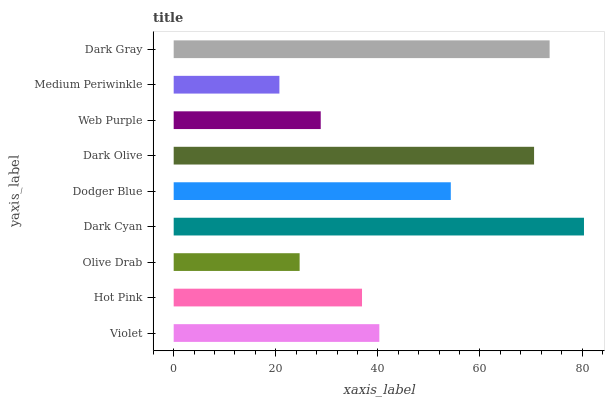Is Medium Periwinkle the minimum?
Answer yes or no. Yes. Is Dark Cyan the maximum?
Answer yes or no. Yes. Is Hot Pink the minimum?
Answer yes or no. No. Is Hot Pink the maximum?
Answer yes or no. No. Is Violet greater than Hot Pink?
Answer yes or no. Yes. Is Hot Pink less than Violet?
Answer yes or no. Yes. Is Hot Pink greater than Violet?
Answer yes or no. No. Is Violet less than Hot Pink?
Answer yes or no. No. Is Violet the high median?
Answer yes or no. Yes. Is Violet the low median?
Answer yes or no. Yes. Is Dark Olive the high median?
Answer yes or no. No. Is Olive Drab the low median?
Answer yes or no. No. 